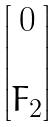Convert formula to latex. <formula><loc_0><loc_0><loc_500><loc_500>\begin{bmatrix} 0 \\ \\ F _ { 2 } \end{bmatrix}</formula> 